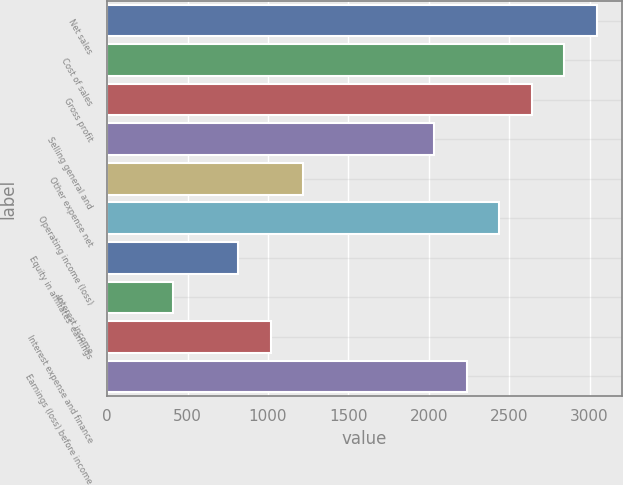Convert chart to OTSL. <chart><loc_0><loc_0><loc_500><loc_500><bar_chart><fcel>Net sales<fcel>Cost of sales<fcel>Gross profit<fcel>Selling general and<fcel>Other expense net<fcel>Operating income (loss)<fcel>Equity in affiliates' earnings<fcel>Interest income<fcel>Interest expense and finance<fcel>Earnings (loss) before income<nl><fcel>3047.51<fcel>2844.39<fcel>2641.26<fcel>2031.88<fcel>1219.38<fcel>2438.14<fcel>813.14<fcel>406.9<fcel>1016.26<fcel>2235.01<nl></chart> 